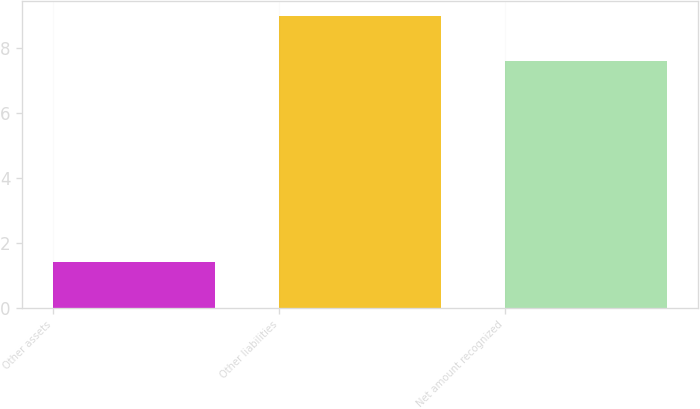Convert chart to OTSL. <chart><loc_0><loc_0><loc_500><loc_500><bar_chart><fcel>Other assets<fcel>Other liabilities<fcel>Net amount recognized<nl><fcel>1.4<fcel>9<fcel>7.6<nl></chart> 